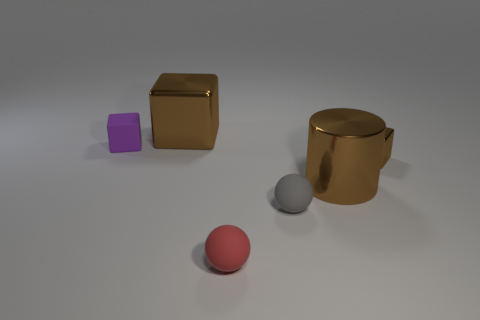What material is the small block that is the same color as the large cylinder?
Offer a very short reply. Metal. How many big things are red matte balls or metal objects?
Offer a very short reply. 2. There is a big brown shiny object behind the tiny purple block; what is its shape?
Your answer should be compact. Cube. Is there another cylinder of the same color as the big cylinder?
Offer a terse response. No. Does the brown block behind the tiny shiny block have the same size as the brown shiny block that is in front of the purple object?
Offer a very short reply. No. Are there more big metal objects that are behind the big metal cube than large brown metallic objects that are in front of the gray object?
Your answer should be very brief. No. Is there a gray cylinder made of the same material as the large block?
Keep it short and to the point. No. Is the cylinder the same color as the small shiny cube?
Offer a very short reply. Yes. There is a small thing that is both to the right of the big metallic block and behind the tiny gray matte sphere; what is its material?
Ensure brevity in your answer.  Metal. What is the color of the rubber cube?
Provide a succinct answer. Purple. 